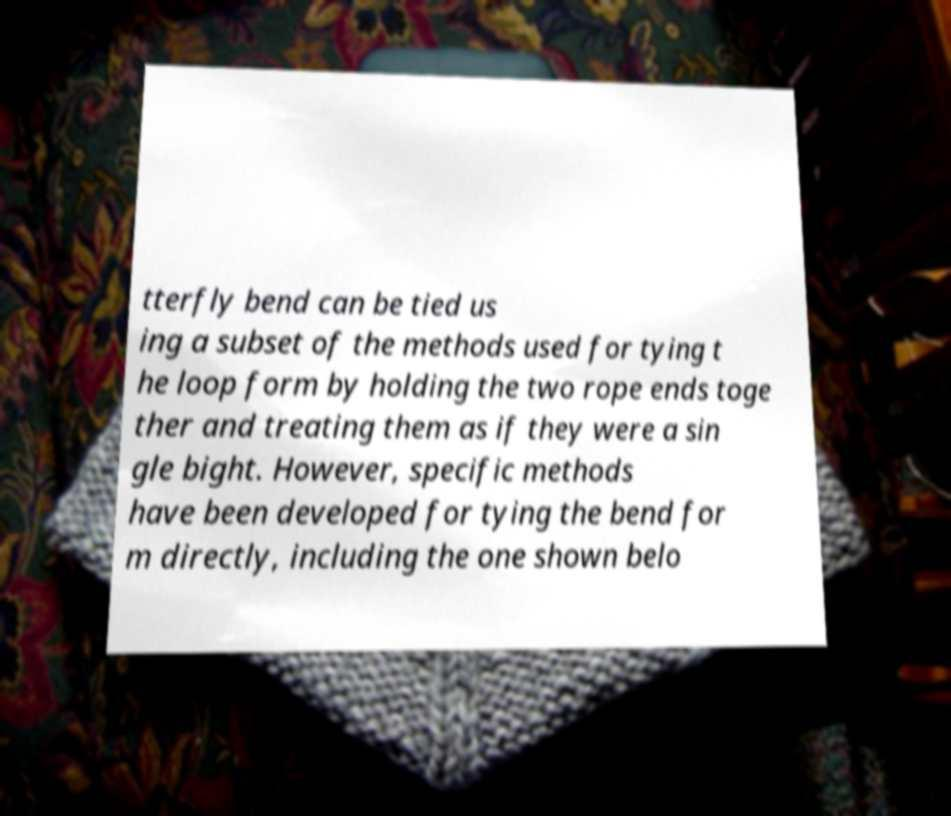Please read and relay the text visible in this image. What does it say? tterfly bend can be tied us ing a subset of the methods used for tying t he loop form by holding the two rope ends toge ther and treating them as if they were a sin gle bight. However, specific methods have been developed for tying the bend for m directly, including the one shown belo 